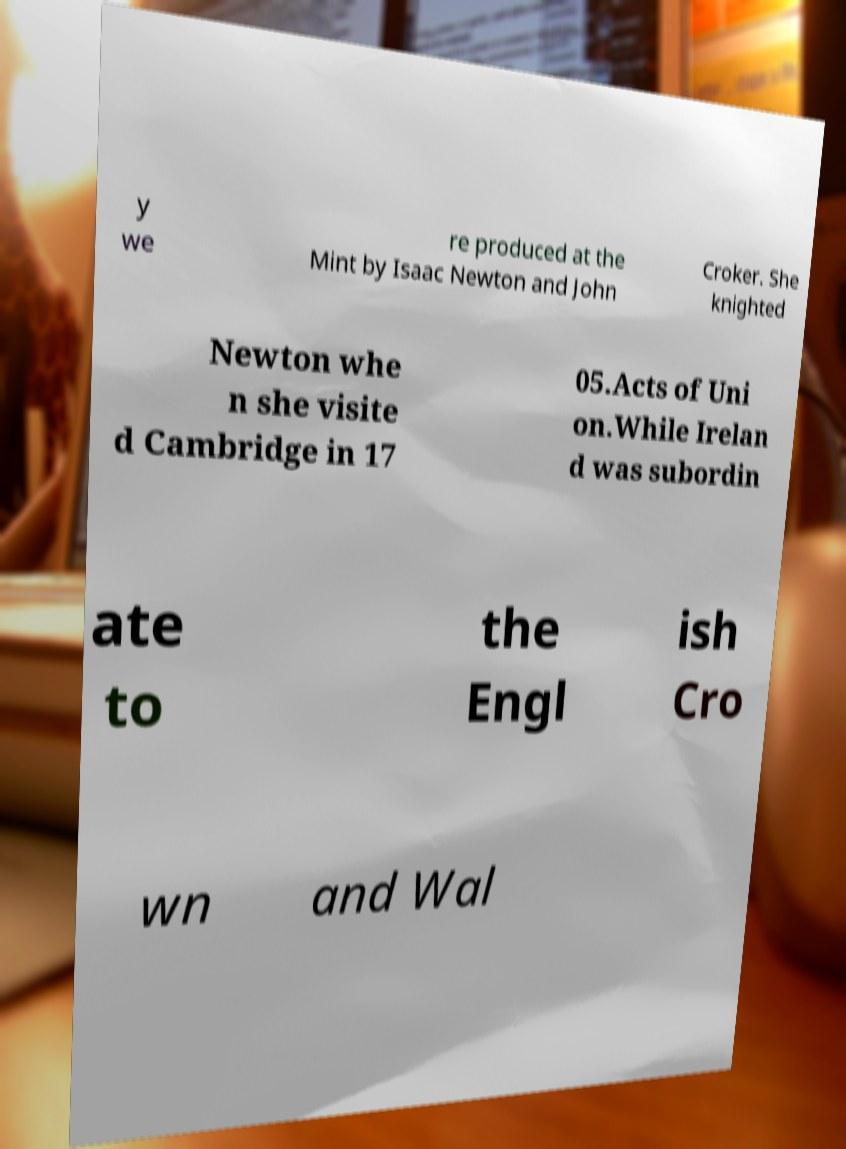I need the written content from this picture converted into text. Can you do that? y we re produced at the Mint by Isaac Newton and John Croker. She knighted Newton whe n she visite d Cambridge in 17 05.Acts of Uni on.While Irelan d was subordin ate to the Engl ish Cro wn and Wal 